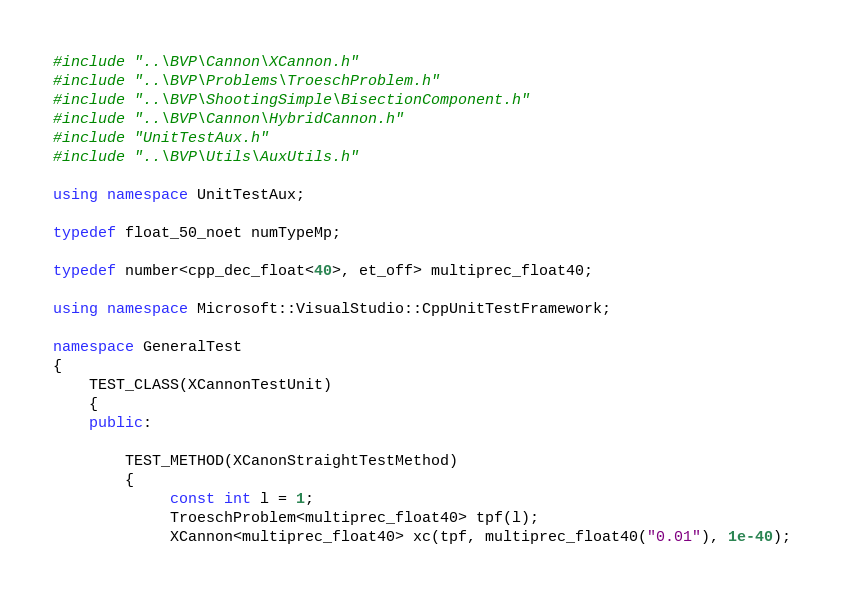Convert code to text. <code><loc_0><loc_0><loc_500><loc_500><_C++_>#include "..\BVP\Cannon\XCannon.h"
#include "..\BVP\Problems\TroeschProblem.h"
#include "..\BVP\ShootingSimple\BisectionComponent.h"
#include "..\BVP\Cannon\HybridCannon.h"
#include "UnitTestAux.h"
#include "..\BVP\Utils\AuxUtils.h"

using namespace UnitTestAux;

typedef float_50_noet numTypeMp;

typedef number<cpp_dec_float<40>, et_off> multiprec_float40;

using namespace Microsoft::VisualStudio::CppUnitTestFramework;

namespace GeneralTest
{
	TEST_CLASS(XCannonTestUnit)
	{
	public:
		
		TEST_METHOD(XCanonStraightTestMethod)
		{
			 const int l = 1;
			 TroeschProblem<multiprec_float40> tpf(l);
			 XCannon<multiprec_float40> xc(tpf, multiprec_float40("0.01"), 1e-40);
</code> 